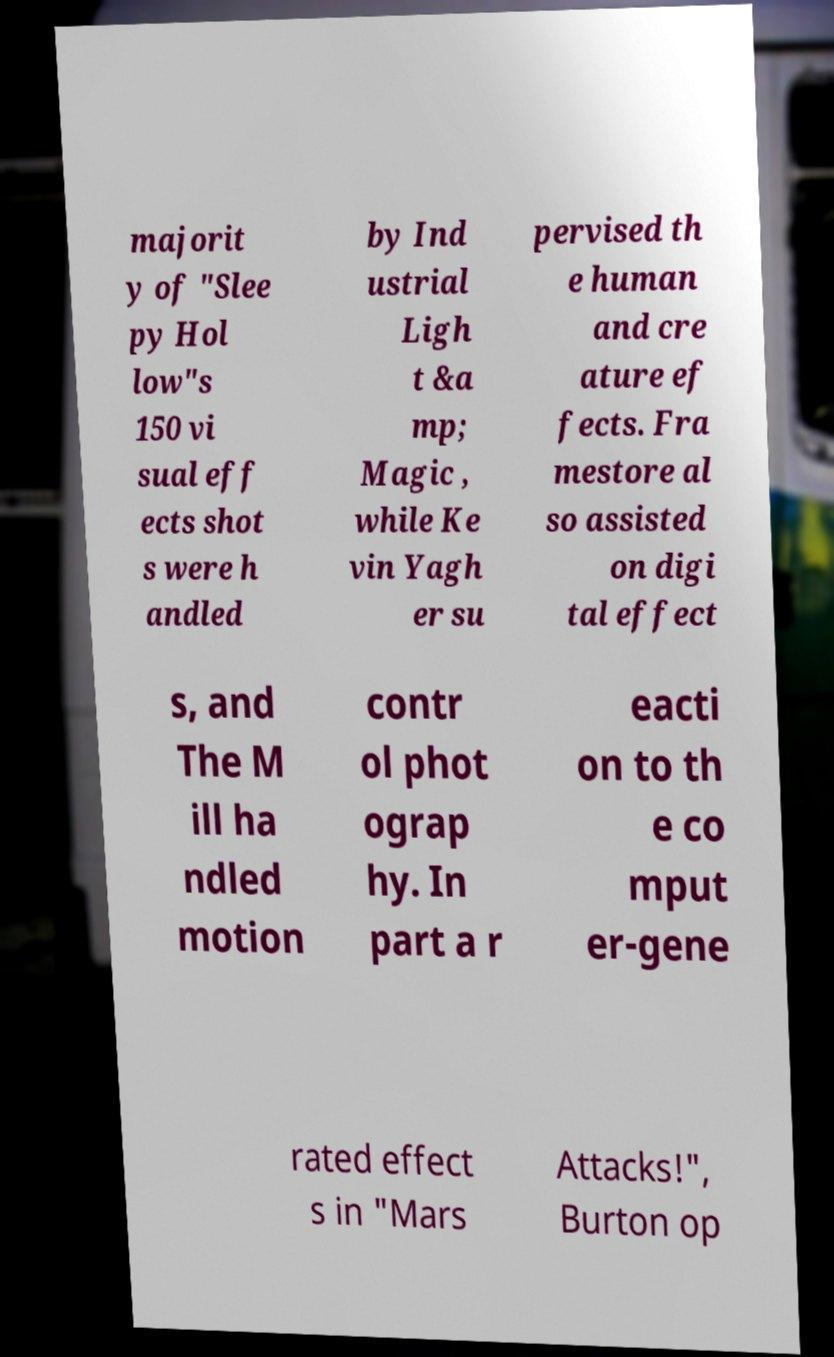Could you extract and type out the text from this image? majorit y of "Slee py Hol low"s 150 vi sual eff ects shot s were h andled by Ind ustrial Ligh t &a mp; Magic , while Ke vin Yagh er su pervised th e human and cre ature ef fects. Fra mestore al so assisted on digi tal effect s, and The M ill ha ndled motion contr ol phot ograp hy. In part a r eacti on to th e co mput er-gene rated effect s in "Mars Attacks!", Burton op 